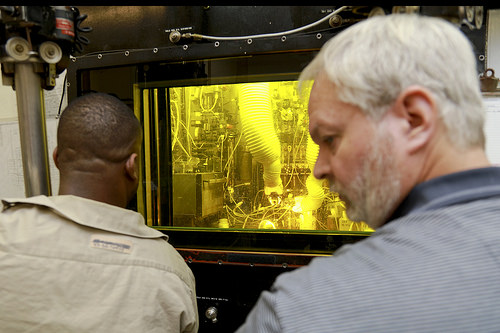<image>
Can you confirm if the wire is on the man? No. The wire is not positioned on the man. They may be near each other, but the wire is not supported by or resting on top of the man. Where is the man in relation to the machine? Is it in front of the machine? Yes. The man is positioned in front of the machine, appearing closer to the camera viewpoint. 